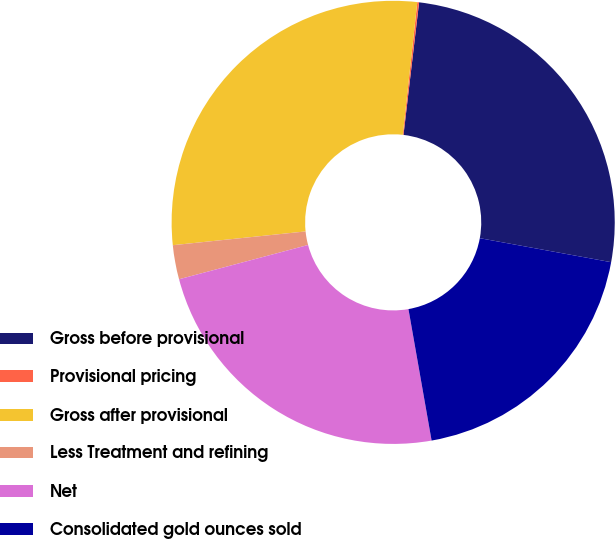Convert chart to OTSL. <chart><loc_0><loc_0><loc_500><loc_500><pie_chart><fcel>Gross before provisional<fcel>Provisional pricing<fcel>Gross after provisional<fcel>Less Treatment and refining<fcel>Net<fcel>Consolidated gold ounces sold<nl><fcel>26.01%<fcel>0.13%<fcel>28.38%<fcel>2.49%<fcel>23.64%<fcel>19.35%<nl></chart> 